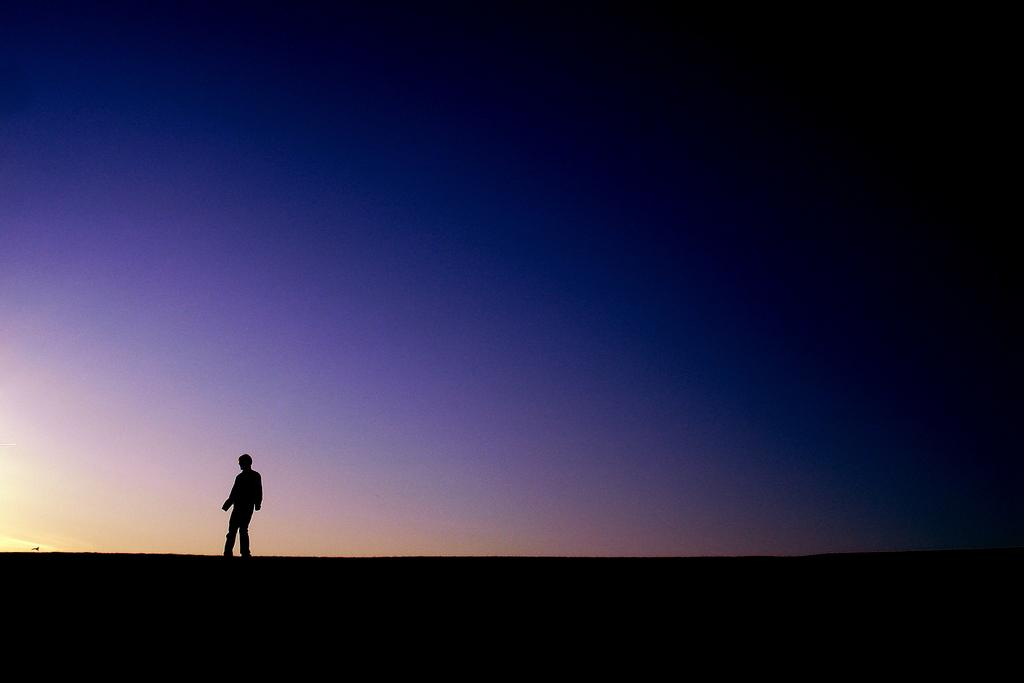What is the main subject of the image? There is a person standing in the image. Can you describe the background of the image? There are multiple colors visible in the background of the image. What type of religious ceremony is taking place in the image? There is no indication of a religious ceremony in the image; it only features a person standing and a colorful background. What type of baked goods can be seen in the image? There are no baked goods, such as loaves or cakes, present in the image. 